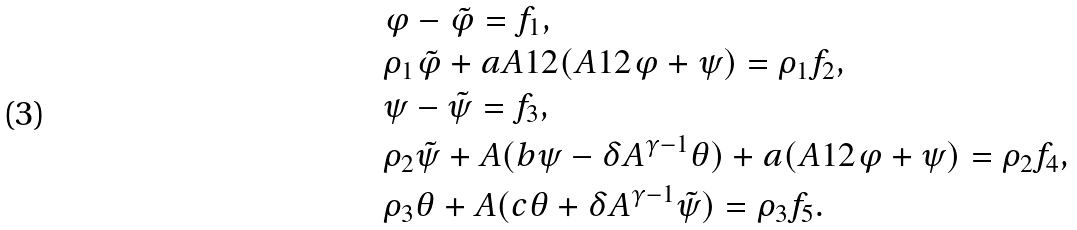Convert formula to latex. <formula><loc_0><loc_0><loc_500><loc_500>& \varphi - \tilde { \varphi } = f _ { 1 } , \\ & \rho _ { 1 } \tilde { \varphi } + a A ^ { } { 1 } 2 ( A ^ { } { 1 } 2 \varphi + \psi ) = \rho _ { 1 } f _ { 2 } , \\ & \psi - \tilde { \psi } = f _ { 3 } , \\ & \rho _ { 2 } \tilde { \psi } + A ( b \psi - \delta A ^ { \gamma - 1 } \theta ) + a ( A ^ { } { 1 } 2 \varphi + \psi ) = \rho _ { 2 } f _ { 4 } , \\ & \rho _ { 3 } \theta + A ( c \theta + \delta A ^ { \gamma - 1 } \tilde { \psi } ) = \rho _ { 3 } f _ { 5 } .</formula> 